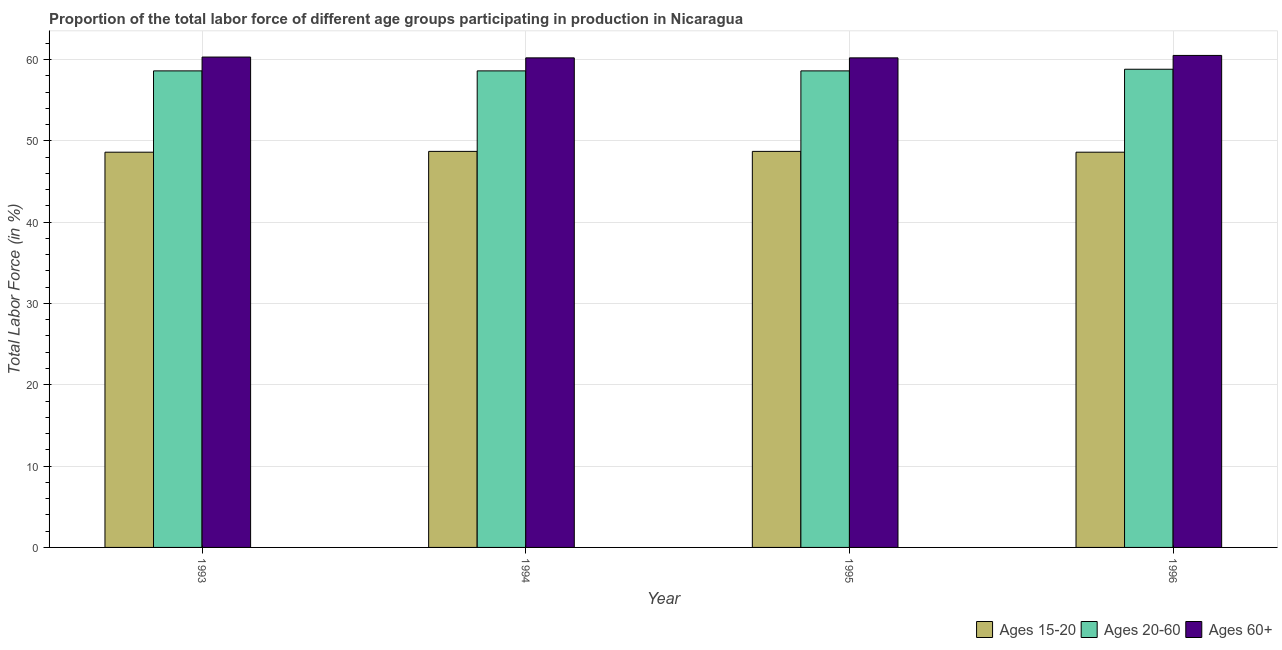Are the number of bars per tick equal to the number of legend labels?
Your answer should be very brief. Yes. Are the number of bars on each tick of the X-axis equal?
Your response must be concise. Yes. How many bars are there on the 3rd tick from the right?
Ensure brevity in your answer.  3. What is the percentage of labor force above age 60 in 1995?
Make the answer very short. 60.2. Across all years, what is the maximum percentage of labor force above age 60?
Give a very brief answer. 60.5. Across all years, what is the minimum percentage of labor force within the age group 15-20?
Ensure brevity in your answer.  48.6. In which year was the percentage of labor force within the age group 15-20 minimum?
Offer a very short reply. 1993. What is the total percentage of labor force within the age group 20-60 in the graph?
Offer a very short reply. 234.6. What is the difference between the percentage of labor force above age 60 in 1994 and that in 1996?
Provide a short and direct response. -0.3. What is the difference between the percentage of labor force within the age group 15-20 in 1993 and the percentage of labor force within the age group 20-60 in 1995?
Your answer should be very brief. -0.1. What is the average percentage of labor force within the age group 15-20 per year?
Your response must be concise. 48.65. In how many years, is the percentage of labor force within the age group 15-20 greater than 44 %?
Keep it short and to the point. 4. What is the difference between the highest and the second highest percentage of labor force above age 60?
Provide a succinct answer. 0.2. What is the difference between the highest and the lowest percentage of labor force within the age group 20-60?
Make the answer very short. 0.2. Is the sum of the percentage of labor force within the age group 15-20 in 1993 and 1994 greater than the maximum percentage of labor force within the age group 20-60 across all years?
Keep it short and to the point. Yes. What does the 1st bar from the left in 1994 represents?
Your answer should be compact. Ages 15-20. What does the 1st bar from the right in 1994 represents?
Your response must be concise. Ages 60+. How many bars are there?
Provide a short and direct response. 12. What is the difference between two consecutive major ticks on the Y-axis?
Provide a short and direct response. 10. Are the values on the major ticks of Y-axis written in scientific E-notation?
Make the answer very short. No. Does the graph contain any zero values?
Your answer should be compact. No. Does the graph contain grids?
Give a very brief answer. Yes. How many legend labels are there?
Keep it short and to the point. 3. What is the title of the graph?
Your answer should be compact. Proportion of the total labor force of different age groups participating in production in Nicaragua. Does "Private sector" appear as one of the legend labels in the graph?
Offer a very short reply. No. What is the Total Labor Force (in %) in Ages 15-20 in 1993?
Your response must be concise. 48.6. What is the Total Labor Force (in %) of Ages 20-60 in 1993?
Your answer should be very brief. 58.6. What is the Total Labor Force (in %) of Ages 60+ in 1993?
Your response must be concise. 60.3. What is the Total Labor Force (in %) of Ages 15-20 in 1994?
Offer a terse response. 48.7. What is the Total Labor Force (in %) in Ages 20-60 in 1994?
Your response must be concise. 58.6. What is the Total Labor Force (in %) of Ages 60+ in 1994?
Your response must be concise. 60.2. What is the Total Labor Force (in %) of Ages 15-20 in 1995?
Your answer should be very brief. 48.7. What is the Total Labor Force (in %) of Ages 20-60 in 1995?
Your answer should be compact. 58.6. What is the Total Labor Force (in %) in Ages 60+ in 1995?
Offer a terse response. 60.2. What is the Total Labor Force (in %) in Ages 15-20 in 1996?
Give a very brief answer. 48.6. What is the Total Labor Force (in %) in Ages 20-60 in 1996?
Keep it short and to the point. 58.8. What is the Total Labor Force (in %) in Ages 60+ in 1996?
Your answer should be compact. 60.5. Across all years, what is the maximum Total Labor Force (in %) of Ages 15-20?
Make the answer very short. 48.7. Across all years, what is the maximum Total Labor Force (in %) in Ages 20-60?
Provide a short and direct response. 58.8. Across all years, what is the maximum Total Labor Force (in %) in Ages 60+?
Offer a very short reply. 60.5. Across all years, what is the minimum Total Labor Force (in %) in Ages 15-20?
Make the answer very short. 48.6. Across all years, what is the minimum Total Labor Force (in %) of Ages 20-60?
Ensure brevity in your answer.  58.6. Across all years, what is the minimum Total Labor Force (in %) of Ages 60+?
Offer a terse response. 60.2. What is the total Total Labor Force (in %) in Ages 15-20 in the graph?
Your response must be concise. 194.6. What is the total Total Labor Force (in %) of Ages 20-60 in the graph?
Keep it short and to the point. 234.6. What is the total Total Labor Force (in %) in Ages 60+ in the graph?
Give a very brief answer. 241.2. What is the difference between the Total Labor Force (in %) of Ages 15-20 in 1993 and that in 1994?
Your answer should be compact. -0.1. What is the difference between the Total Labor Force (in %) in Ages 20-60 in 1993 and that in 1994?
Ensure brevity in your answer.  0. What is the difference between the Total Labor Force (in %) in Ages 15-20 in 1993 and that in 1995?
Your answer should be compact. -0.1. What is the difference between the Total Labor Force (in %) in Ages 20-60 in 1993 and that in 1995?
Your response must be concise. 0. What is the difference between the Total Labor Force (in %) in Ages 60+ in 1993 and that in 1995?
Give a very brief answer. 0.1. What is the difference between the Total Labor Force (in %) in Ages 20-60 in 1993 and that in 1996?
Give a very brief answer. -0.2. What is the difference between the Total Labor Force (in %) of Ages 15-20 in 1994 and that in 1995?
Ensure brevity in your answer.  0. What is the difference between the Total Labor Force (in %) in Ages 20-60 in 1994 and that in 1995?
Give a very brief answer. 0. What is the difference between the Total Labor Force (in %) of Ages 15-20 in 1994 and that in 1996?
Offer a terse response. 0.1. What is the difference between the Total Labor Force (in %) in Ages 60+ in 1994 and that in 1996?
Your answer should be compact. -0.3. What is the difference between the Total Labor Force (in %) of Ages 15-20 in 1993 and the Total Labor Force (in %) of Ages 20-60 in 1994?
Ensure brevity in your answer.  -10. What is the difference between the Total Labor Force (in %) of Ages 20-60 in 1993 and the Total Labor Force (in %) of Ages 60+ in 1994?
Your response must be concise. -1.6. What is the difference between the Total Labor Force (in %) of Ages 15-20 in 1993 and the Total Labor Force (in %) of Ages 20-60 in 1995?
Your answer should be compact. -10. What is the difference between the Total Labor Force (in %) of Ages 15-20 in 1993 and the Total Labor Force (in %) of Ages 60+ in 1995?
Offer a very short reply. -11.6. What is the difference between the Total Labor Force (in %) of Ages 15-20 in 1993 and the Total Labor Force (in %) of Ages 60+ in 1996?
Provide a succinct answer. -11.9. What is the difference between the Total Labor Force (in %) of Ages 15-20 in 1994 and the Total Labor Force (in %) of Ages 60+ in 1995?
Provide a short and direct response. -11.5. What is the difference between the Total Labor Force (in %) of Ages 15-20 in 1994 and the Total Labor Force (in %) of Ages 20-60 in 1996?
Give a very brief answer. -10.1. What is the difference between the Total Labor Force (in %) of Ages 15-20 in 1994 and the Total Labor Force (in %) of Ages 60+ in 1996?
Your answer should be very brief. -11.8. What is the difference between the Total Labor Force (in %) in Ages 15-20 in 1995 and the Total Labor Force (in %) in Ages 60+ in 1996?
Your answer should be compact. -11.8. What is the average Total Labor Force (in %) in Ages 15-20 per year?
Keep it short and to the point. 48.65. What is the average Total Labor Force (in %) of Ages 20-60 per year?
Your answer should be very brief. 58.65. What is the average Total Labor Force (in %) in Ages 60+ per year?
Offer a terse response. 60.3. In the year 1993, what is the difference between the Total Labor Force (in %) in Ages 15-20 and Total Labor Force (in %) in Ages 60+?
Your answer should be very brief. -11.7. In the year 1994, what is the difference between the Total Labor Force (in %) of Ages 20-60 and Total Labor Force (in %) of Ages 60+?
Offer a very short reply. -1.6. In the year 1995, what is the difference between the Total Labor Force (in %) of Ages 15-20 and Total Labor Force (in %) of Ages 20-60?
Provide a short and direct response. -9.9. In the year 1995, what is the difference between the Total Labor Force (in %) of Ages 20-60 and Total Labor Force (in %) of Ages 60+?
Offer a very short reply. -1.6. In the year 1996, what is the difference between the Total Labor Force (in %) of Ages 15-20 and Total Labor Force (in %) of Ages 20-60?
Give a very brief answer. -10.2. In the year 1996, what is the difference between the Total Labor Force (in %) in Ages 15-20 and Total Labor Force (in %) in Ages 60+?
Offer a very short reply. -11.9. In the year 1996, what is the difference between the Total Labor Force (in %) in Ages 20-60 and Total Labor Force (in %) in Ages 60+?
Your answer should be very brief. -1.7. What is the ratio of the Total Labor Force (in %) in Ages 15-20 in 1993 to that in 1994?
Your answer should be compact. 1. What is the ratio of the Total Labor Force (in %) in Ages 60+ in 1993 to that in 1994?
Provide a succinct answer. 1. What is the ratio of the Total Labor Force (in %) of Ages 60+ in 1993 to that in 1995?
Offer a terse response. 1. What is the ratio of the Total Labor Force (in %) of Ages 20-60 in 1993 to that in 1996?
Your response must be concise. 1. What is the ratio of the Total Labor Force (in %) of Ages 60+ in 1993 to that in 1996?
Keep it short and to the point. 1. What is the ratio of the Total Labor Force (in %) in Ages 15-20 in 1994 to that in 1995?
Offer a very short reply. 1. What is the ratio of the Total Labor Force (in %) in Ages 60+ in 1994 to that in 1995?
Give a very brief answer. 1. What is the ratio of the Total Labor Force (in %) in Ages 15-20 in 1994 to that in 1996?
Ensure brevity in your answer.  1. What is the ratio of the Total Labor Force (in %) in Ages 20-60 in 1994 to that in 1996?
Offer a very short reply. 1. What is the ratio of the Total Labor Force (in %) of Ages 60+ in 1994 to that in 1996?
Offer a very short reply. 0.99. What is the ratio of the Total Labor Force (in %) of Ages 20-60 in 1995 to that in 1996?
Your response must be concise. 1. What is the difference between the highest and the second highest Total Labor Force (in %) in Ages 60+?
Offer a terse response. 0.2. What is the difference between the highest and the lowest Total Labor Force (in %) of Ages 15-20?
Make the answer very short. 0.1. What is the difference between the highest and the lowest Total Labor Force (in %) of Ages 20-60?
Your answer should be compact. 0.2. 